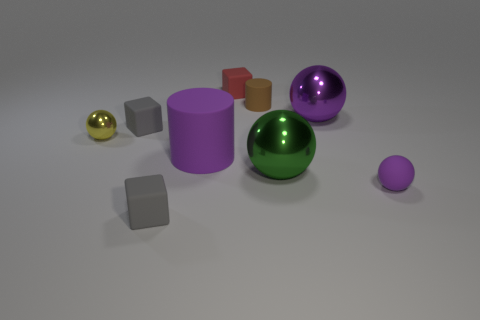What number of metallic objects are behind the small brown rubber cylinder?
Your response must be concise. 0. How many small red cubes have the same material as the purple cylinder?
Your response must be concise. 1. What is the color of the tiny cylinder that is the same material as the big cylinder?
Keep it short and to the point. Brown. There is a purple object behind the small gray matte thing that is behind the purple sphere that is in front of the purple metallic object; what is its material?
Your answer should be very brief. Metal. Does the purple thing left of the green ball have the same size as the yellow shiny sphere?
Ensure brevity in your answer.  No. What number of tiny things are either gray objects or cyan matte cylinders?
Give a very brief answer. 2. Is there a matte object of the same color as the tiny matte ball?
Your response must be concise. Yes. What is the shape of the brown matte thing that is the same size as the yellow object?
Offer a very short reply. Cylinder. There is a sphere on the left side of the large green thing; is its color the same as the tiny cylinder?
Keep it short and to the point. No. What number of things are tiny matte blocks in front of the small rubber cylinder or rubber spheres?
Your response must be concise. 3. 